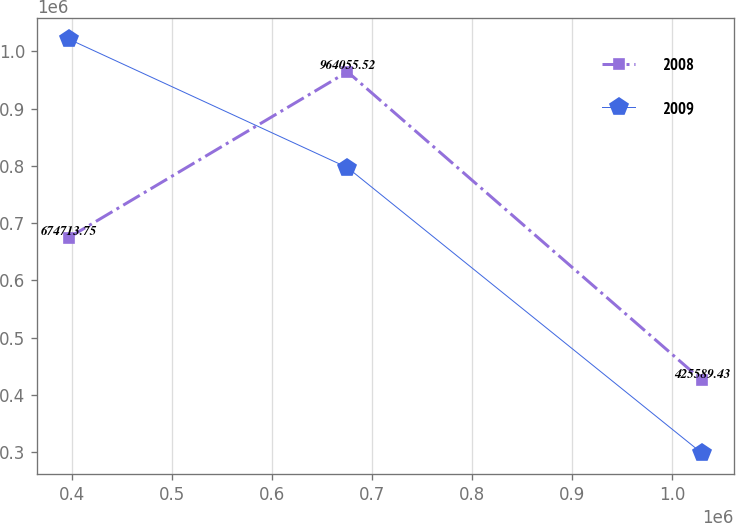<chart> <loc_0><loc_0><loc_500><loc_500><line_chart><ecel><fcel>2008<fcel>2009<nl><fcel>396541<fcel>674714<fcel>1.02127e+06<nl><fcel>675285<fcel>964056<fcel>796903<nl><fcel>1.02976e+06<fcel>425589<fcel>298428<nl></chart> 